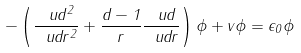Convert formula to latex. <formula><loc_0><loc_0><loc_500><loc_500>- \left ( \frac { \ u d ^ { 2 } } { \ u d r ^ { 2 } } + \frac { d - 1 } { r } \frac { \ u d } { \ u d r } \right ) \phi + v \phi = \epsilon _ { 0 } \phi</formula> 